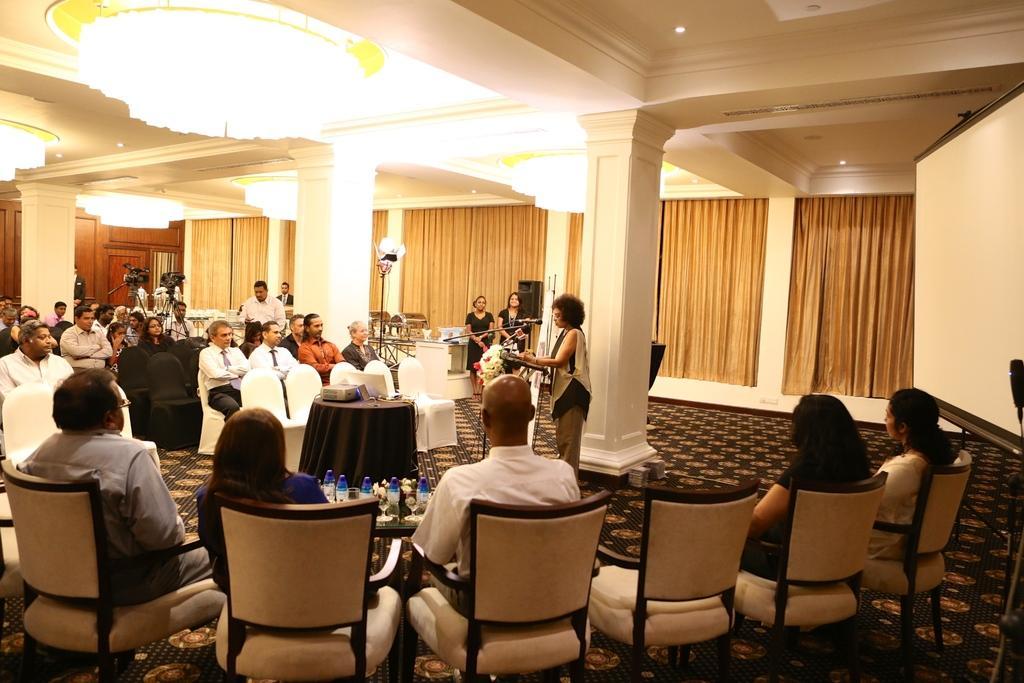Can you describe this image briefly? In the foreground of the image there are six chairs in which five are occupied. There is a woman standing at the podium and speaking. There is a projector on the table. In the background of the image there are video cameras curtains on the wall. 